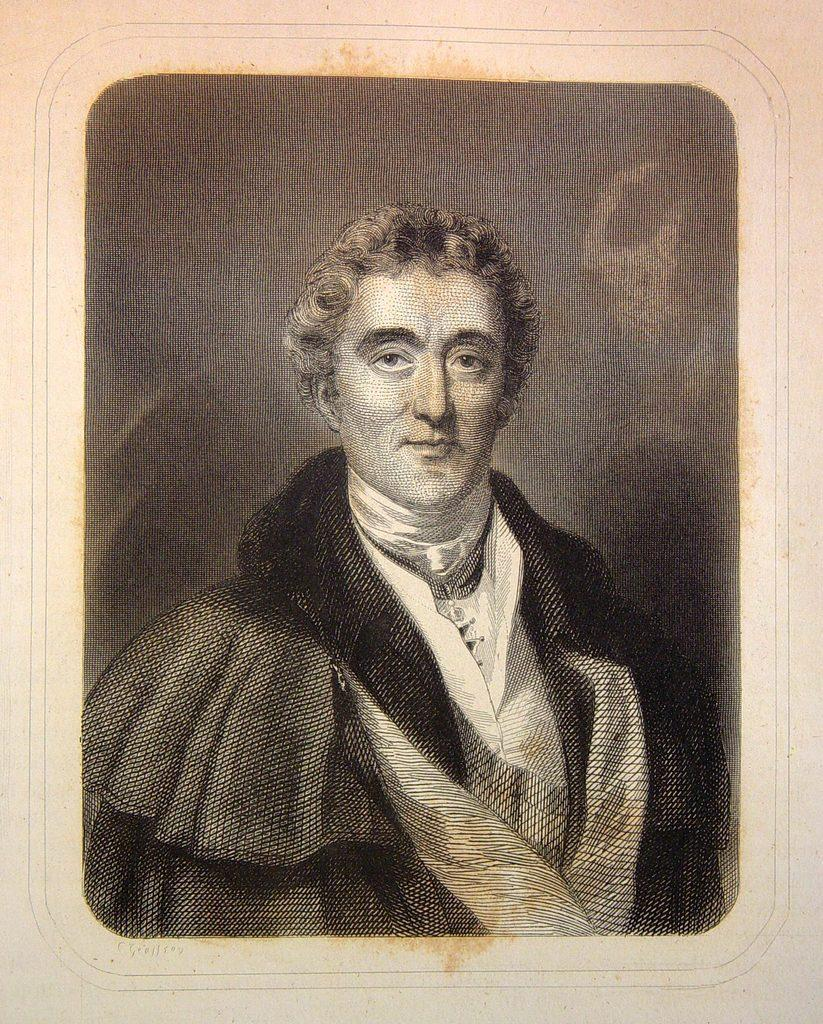Who is present in the image? There is a man in the image. What type of oil is the man using to cook in the image? There is no oil or cooking activity present in the image; it only features a man. 